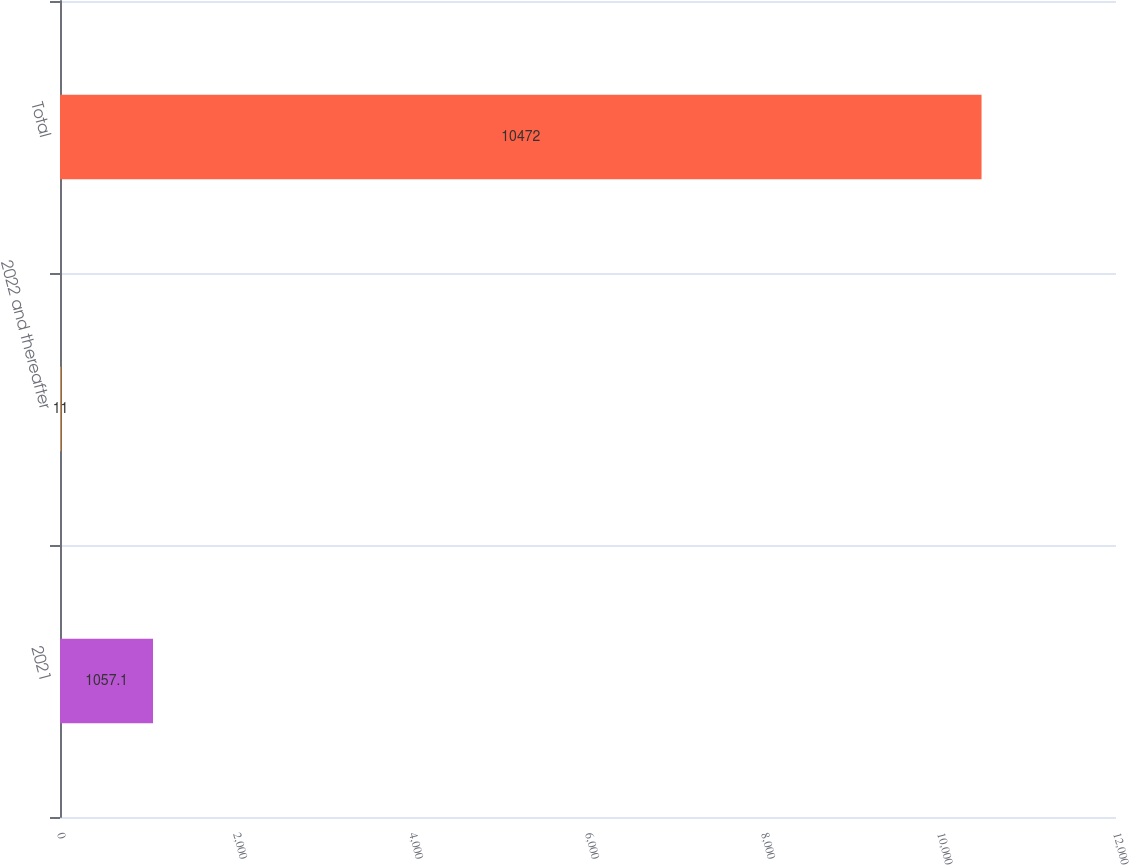Convert chart to OTSL. <chart><loc_0><loc_0><loc_500><loc_500><bar_chart><fcel>2021<fcel>2022 and thereafter<fcel>Total<nl><fcel>1057.1<fcel>11<fcel>10472<nl></chart> 